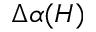<formula> <loc_0><loc_0><loc_500><loc_500>\Delta \alpha ( H )</formula> 